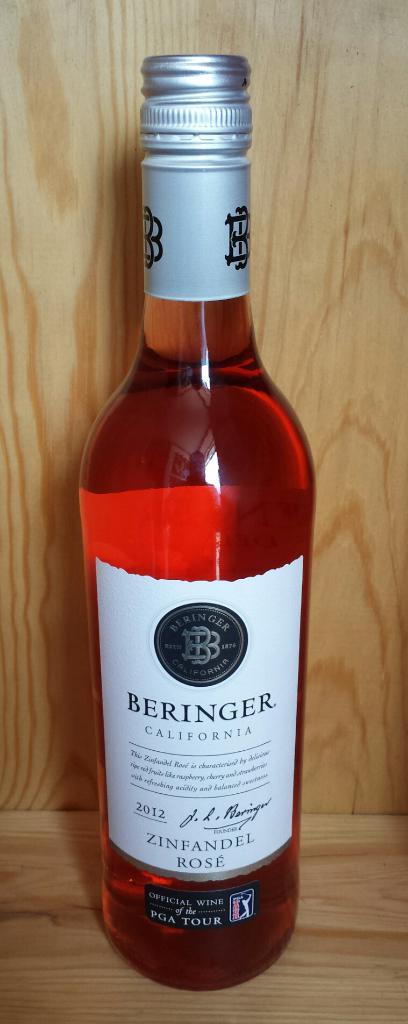What brand of wine is this?
Your answer should be compact. Beringer. 